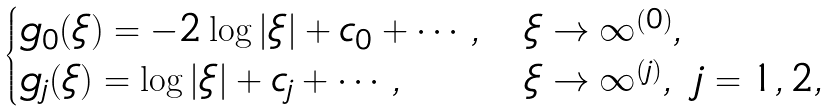Convert formula to latex. <formula><loc_0><loc_0><loc_500><loc_500>\begin{cases} g _ { 0 } ( \xi ) = - 2 \log | \xi | + c _ { 0 } + \cdots , & \xi \to \infty ^ { ( 0 ) } , \\ g _ { j } ( \xi ) = \log | \xi | + c _ { j } + \cdots , & \xi \to \infty ^ { ( j ) } , \ j = 1 , 2 , \end{cases}</formula> 